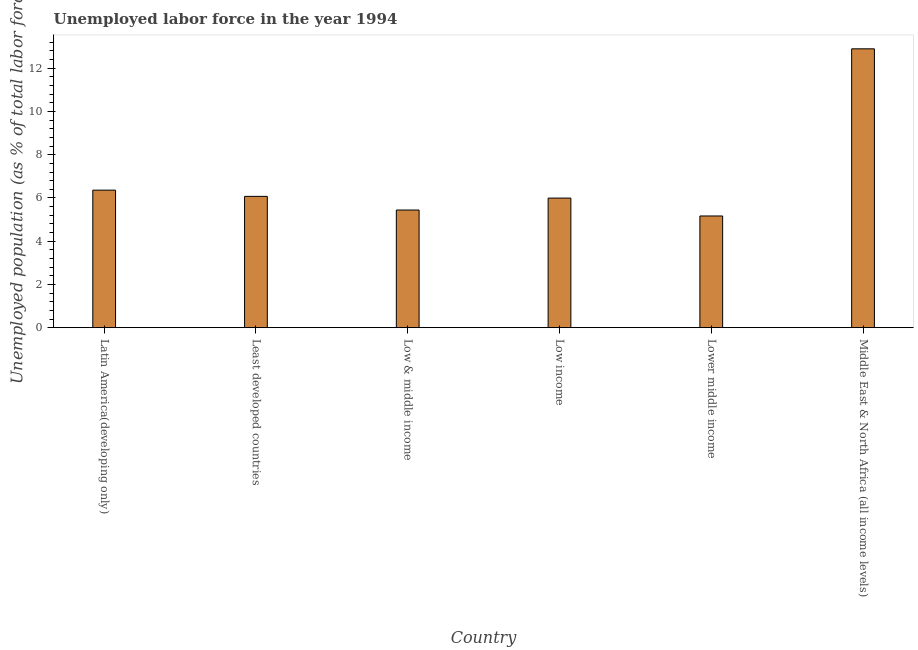Does the graph contain any zero values?
Provide a succinct answer. No. What is the title of the graph?
Offer a terse response. Unemployed labor force in the year 1994. What is the label or title of the X-axis?
Your response must be concise. Country. What is the label or title of the Y-axis?
Offer a terse response. Unemployed population (as % of total labor force). What is the total unemployed population in Middle East & North Africa (all income levels)?
Your answer should be very brief. 12.9. Across all countries, what is the maximum total unemployed population?
Your answer should be compact. 12.9. Across all countries, what is the minimum total unemployed population?
Your response must be concise. 5.17. In which country was the total unemployed population maximum?
Your answer should be compact. Middle East & North Africa (all income levels). In which country was the total unemployed population minimum?
Your response must be concise. Lower middle income. What is the sum of the total unemployed population?
Keep it short and to the point. 41.94. What is the difference between the total unemployed population in Low income and Lower middle income?
Your response must be concise. 0.83. What is the average total unemployed population per country?
Keep it short and to the point. 6.99. What is the median total unemployed population?
Your answer should be compact. 6.03. What is the ratio of the total unemployed population in Latin America(developing only) to that in Least developed countries?
Make the answer very short. 1.05. Is the total unemployed population in Latin America(developing only) less than that in Least developed countries?
Keep it short and to the point. No. What is the difference between the highest and the second highest total unemployed population?
Give a very brief answer. 6.54. Is the sum of the total unemployed population in Low income and Middle East & North Africa (all income levels) greater than the maximum total unemployed population across all countries?
Offer a very short reply. Yes. What is the difference between the highest and the lowest total unemployed population?
Provide a succinct answer. 7.73. How many countries are there in the graph?
Provide a short and direct response. 6. Are the values on the major ticks of Y-axis written in scientific E-notation?
Keep it short and to the point. No. What is the Unemployed population (as % of total labor force) in Latin America(developing only)?
Your answer should be compact. 6.36. What is the Unemployed population (as % of total labor force) of Least developed countries?
Make the answer very short. 6.07. What is the Unemployed population (as % of total labor force) of Low & middle income?
Give a very brief answer. 5.44. What is the Unemployed population (as % of total labor force) in Low income?
Your answer should be compact. 5.99. What is the Unemployed population (as % of total labor force) in Lower middle income?
Ensure brevity in your answer.  5.17. What is the Unemployed population (as % of total labor force) of Middle East & North Africa (all income levels)?
Keep it short and to the point. 12.9. What is the difference between the Unemployed population (as % of total labor force) in Latin America(developing only) and Least developed countries?
Keep it short and to the point. 0.29. What is the difference between the Unemployed population (as % of total labor force) in Latin America(developing only) and Low & middle income?
Offer a very short reply. 0.92. What is the difference between the Unemployed population (as % of total labor force) in Latin America(developing only) and Low income?
Provide a short and direct response. 0.37. What is the difference between the Unemployed population (as % of total labor force) in Latin America(developing only) and Lower middle income?
Offer a terse response. 1.19. What is the difference between the Unemployed population (as % of total labor force) in Latin America(developing only) and Middle East & North Africa (all income levels)?
Ensure brevity in your answer.  -6.54. What is the difference between the Unemployed population (as % of total labor force) in Least developed countries and Low & middle income?
Provide a short and direct response. 0.63. What is the difference between the Unemployed population (as % of total labor force) in Least developed countries and Low income?
Offer a very short reply. 0.08. What is the difference between the Unemployed population (as % of total labor force) in Least developed countries and Lower middle income?
Provide a short and direct response. 0.91. What is the difference between the Unemployed population (as % of total labor force) in Least developed countries and Middle East & North Africa (all income levels)?
Offer a terse response. -6.83. What is the difference between the Unemployed population (as % of total labor force) in Low & middle income and Low income?
Your response must be concise. -0.55. What is the difference between the Unemployed population (as % of total labor force) in Low & middle income and Lower middle income?
Your answer should be very brief. 0.27. What is the difference between the Unemployed population (as % of total labor force) in Low & middle income and Middle East & North Africa (all income levels)?
Your answer should be very brief. -7.46. What is the difference between the Unemployed population (as % of total labor force) in Low income and Lower middle income?
Offer a very short reply. 0.83. What is the difference between the Unemployed population (as % of total labor force) in Low income and Middle East & North Africa (all income levels)?
Your response must be concise. -6.9. What is the difference between the Unemployed population (as % of total labor force) in Lower middle income and Middle East & North Africa (all income levels)?
Provide a succinct answer. -7.73. What is the ratio of the Unemployed population (as % of total labor force) in Latin America(developing only) to that in Least developed countries?
Your answer should be very brief. 1.05. What is the ratio of the Unemployed population (as % of total labor force) in Latin America(developing only) to that in Low & middle income?
Your answer should be compact. 1.17. What is the ratio of the Unemployed population (as % of total labor force) in Latin America(developing only) to that in Low income?
Your answer should be very brief. 1.06. What is the ratio of the Unemployed population (as % of total labor force) in Latin America(developing only) to that in Lower middle income?
Your answer should be very brief. 1.23. What is the ratio of the Unemployed population (as % of total labor force) in Latin America(developing only) to that in Middle East & North Africa (all income levels)?
Keep it short and to the point. 0.49. What is the ratio of the Unemployed population (as % of total labor force) in Least developed countries to that in Low & middle income?
Make the answer very short. 1.12. What is the ratio of the Unemployed population (as % of total labor force) in Least developed countries to that in Low income?
Provide a short and direct response. 1.01. What is the ratio of the Unemployed population (as % of total labor force) in Least developed countries to that in Lower middle income?
Your answer should be compact. 1.18. What is the ratio of the Unemployed population (as % of total labor force) in Least developed countries to that in Middle East & North Africa (all income levels)?
Offer a terse response. 0.47. What is the ratio of the Unemployed population (as % of total labor force) in Low & middle income to that in Low income?
Your answer should be compact. 0.91. What is the ratio of the Unemployed population (as % of total labor force) in Low & middle income to that in Lower middle income?
Offer a very short reply. 1.05. What is the ratio of the Unemployed population (as % of total labor force) in Low & middle income to that in Middle East & North Africa (all income levels)?
Ensure brevity in your answer.  0.42. What is the ratio of the Unemployed population (as % of total labor force) in Low income to that in Lower middle income?
Offer a terse response. 1.16. What is the ratio of the Unemployed population (as % of total labor force) in Low income to that in Middle East & North Africa (all income levels)?
Offer a terse response. 0.47. What is the ratio of the Unemployed population (as % of total labor force) in Lower middle income to that in Middle East & North Africa (all income levels)?
Provide a succinct answer. 0.4. 